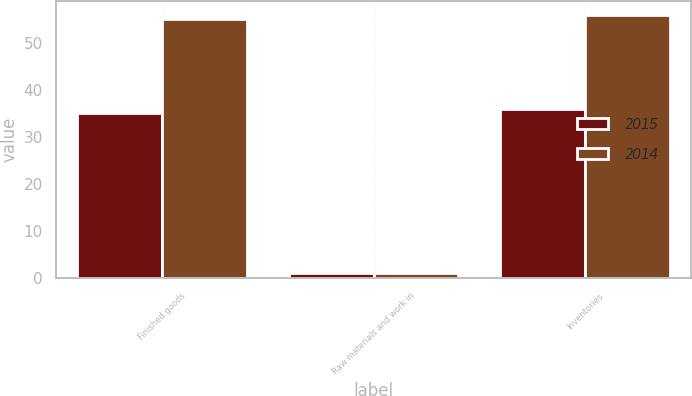<chart> <loc_0><loc_0><loc_500><loc_500><stacked_bar_chart><ecel><fcel>Finished goods<fcel>Raw materials and work in<fcel>Inventories<nl><fcel>2015<fcel>35<fcel>1<fcel>36<nl><fcel>2014<fcel>55<fcel>1<fcel>56<nl></chart> 